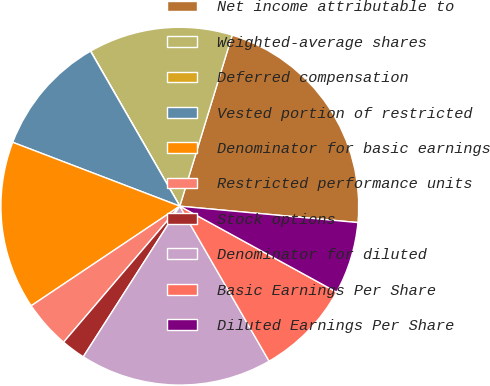<chart> <loc_0><loc_0><loc_500><loc_500><pie_chart><fcel>Net income attributable to<fcel>Weighted-average shares<fcel>Deferred compensation<fcel>Vested portion of restricted<fcel>Denominator for basic earnings<fcel>Restricted performance units<fcel>Stock options<fcel>Denominator for diluted<fcel>Basic Earnings Per Share<fcel>Diluted Earnings Per Share<nl><fcel>21.73%<fcel>13.04%<fcel>0.01%<fcel>10.87%<fcel>15.21%<fcel>4.35%<fcel>2.18%<fcel>17.39%<fcel>8.7%<fcel>6.52%<nl></chart> 